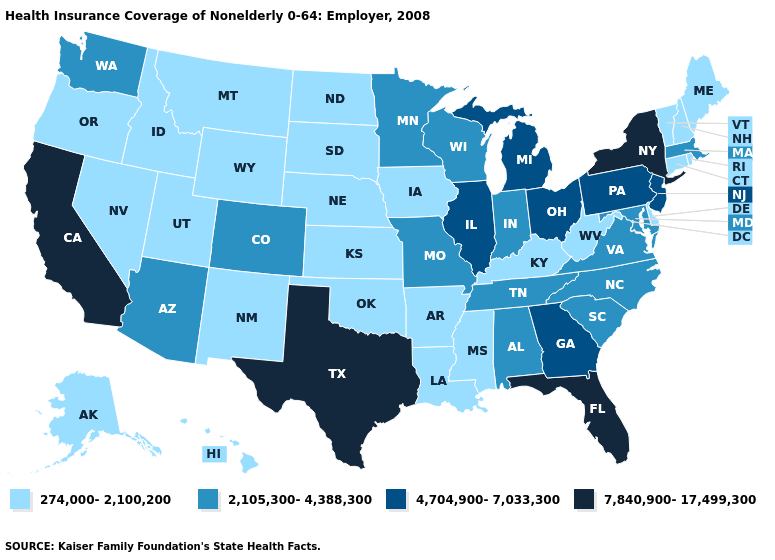Does the first symbol in the legend represent the smallest category?
Concise answer only. Yes. Does Oregon have a lower value than Georgia?
Concise answer only. Yes. What is the lowest value in the MidWest?
Be succinct. 274,000-2,100,200. Name the states that have a value in the range 7,840,900-17,499,300?
Give a very brief answer. California, Florida, New York, Texas. Does Vermont have a lower value than Iowa?
Answer briefly. No. Among the states that border Michigan , does Wisconsin have the highest value?
Short answer required. No. Name the states that have a value in the range 7,840,900-17,499,300?
Quick response, please. California, Florida, New York, Texas. Which states hav the highest value in the West?
Be succinct. California. Is the legend a continuous bar?
Answer briefly. No. Does Rhode Island have the lowest value in the USA?
Be succinct. Yes. How many symbols are there in the legend?
Write a very short answer. 4. Among the states that border South Dakota , does Nebraska have the lowest value?
Keep it brief. Yes. What is the lowest value in the USA?
Be succinct. 274,000-2,100,200. What is the lowest value in states that border Maine?
Quick response, please. 274,000-2,100,200. Which states hav the highest value in the Northeast?
Concise answer only. New York. 